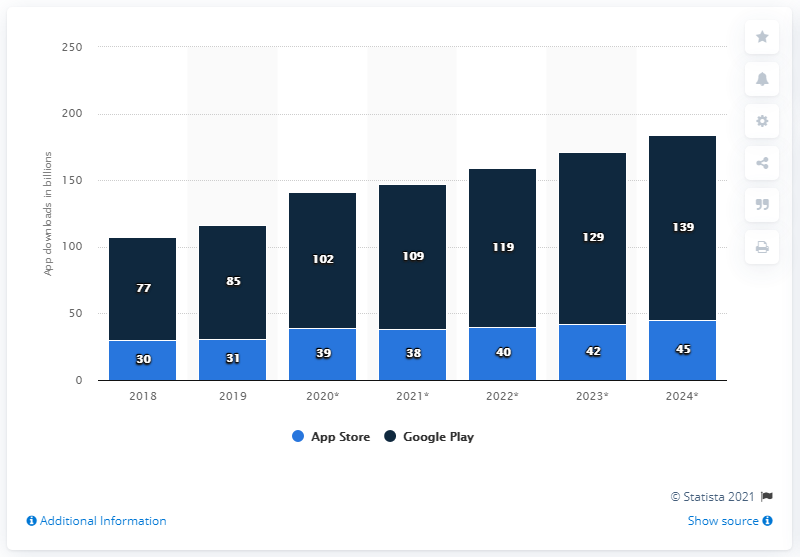Mention a couple of crucial points in this snapshot. In 2019, 102 apps were downloaded from the Google Play Store. In 2024, the Google Play Store was downloaded 139 times by users. 